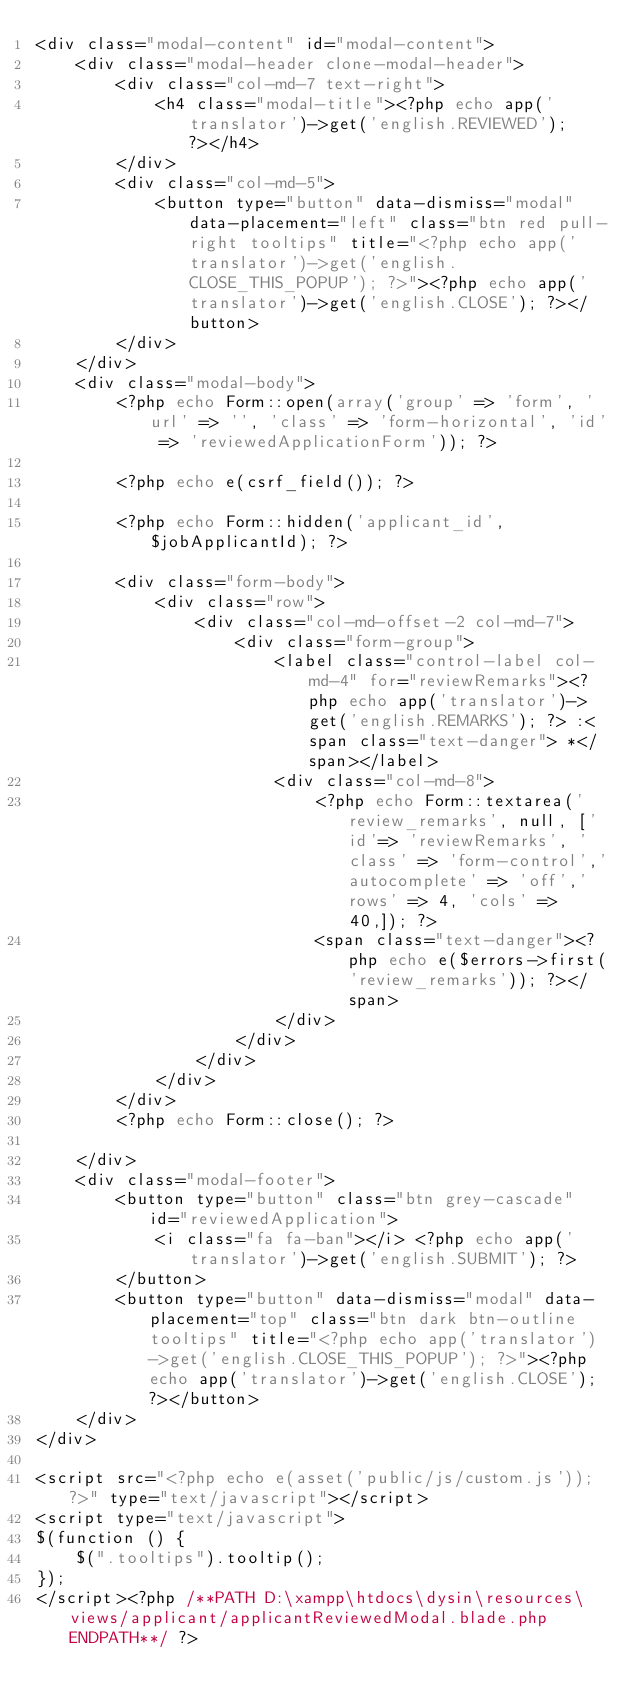<code> <loc_0><loc_0><loc_500><loc_500><_PHP_><div class="modal-content" id="modal-content">
    <div class="modal-header clone-modal-header">
        <div class="col-md-7 text-right">
            <h4 class="modal-title"><?php echo app('translator')->get('english.REVIEWED'); ?></h4>
        </div>
        <div class="col-md-5">
            <button type="button" data-dismiss="modal" data-placement="left" class="btn red pull-right tooltips" title="<?php echo app('translator')->get('english.CLOSE_THIS_POPUP'); ?>"><?php echo app('translator')->get('english.CLOSE'); ?></button>
        </div>
    </div>
    <div class="modal-body">
        <?php echo Form::open(array('group' => 'form', 'url' => '', 'class' => 'form-horizontal', 'id' => 'reviewedApplicationForm')); ?>

        <?php echo e(csrf_field()); ?>

        <?php echo Form::hidden('applicant_id', $jobApplicantId); ?>

        <div class="form-body">
            <div class="row">
                <div class="col-md-offset-2 col-md-7">
                    <div class="form-group">
                        <label class="control-label col-md-4" for="reviewRemarks"><?php echo app('translator')->get('english.REMARKS'); ?> :<span class="text-danger"> *</span></label>
                        <div class="col-md-8">
                            <?php echo Form::textarea('review_remarks', null, ['id'=> 'reviewRemarks', 'class' => 'form-control','autocomplete' => 'off','rows' => 4, 'cols' => 40,]); ?> 
                            <span class="text-danger"><?php echo e($errors->first('review_remarks')); ?></span>
                        </div>
                    </div>
                </div>
            </div>
        </div>
        <?php echo Form::close(); ?>

    </div>
    <div class="modal-footer">
        <button type="button" class="btn grey-cascade"  id="reviewedApplication">
            <i class="fa fa-ban"></i> <?php echo app('translator')->get('english.SUBMIT'); ?>
        </button>
        <button type="button" data-dismiss="modal" data-placement="top" class="btn dark btn-outline tooltips" title="<?php echo app('translator')->get('english.CLOSE_THIS_POPUP'); ?>"><?php echo app('translator')->get('english.CLOSE'); ?></button>
    </div>
</div>

<script src="<?php echo e(asset('public/js/custom.js')); ?>" type="text/javascript"></script>
<script type="text/javascript">
$(function () {
    $(".tooltips").tooltip();
});
</script><?php /**PATH D:\xampp\htdocs\dysin\resources\views/applicant/applicantReviewedModal.blade.php ENDPATH**/ ?></code> 